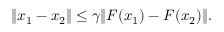Convert formula to latex. <formula><loc_0><loc_0><loc_500><loc_500>\begin{array} { r } { \| x _ { 1 } - x _ { 2 } \| \leq \gamma \| F ( x _ { 1 } ) - F ( x _ { 2 } ) \| . } \end{array}</formula> 